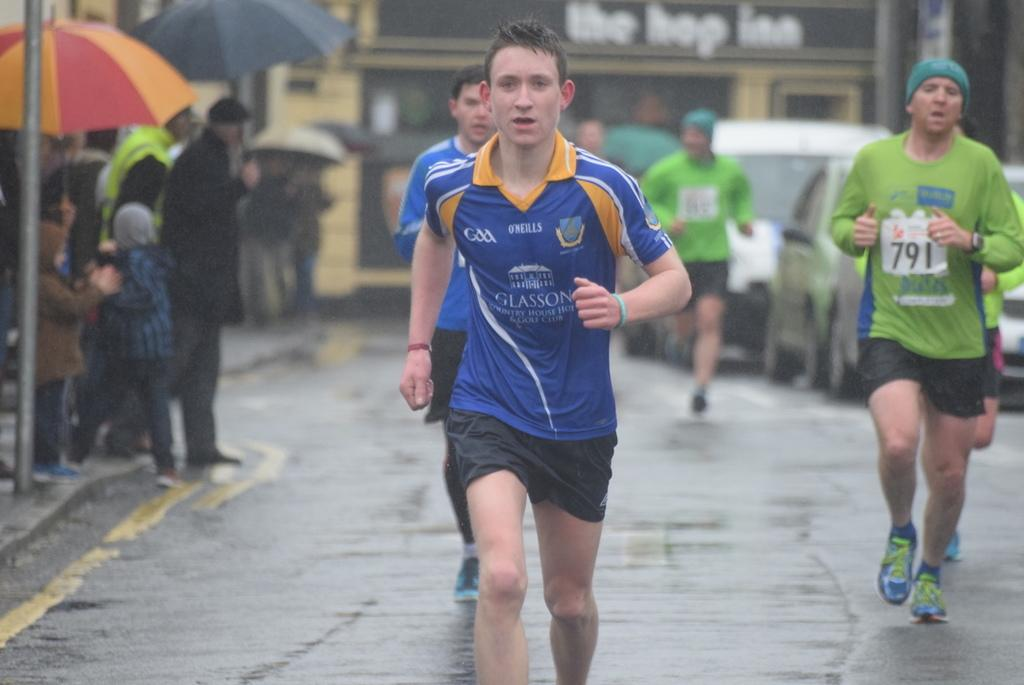Who or what can be seen in the image? There are people in the image. What else is present in the image besides people? There are cars and buildings in the image. Are there any objects in the image that might be used for protection from the elements? Yes, there are umbrellas in the image. What type of plastic is used to make the stick in the image? There is no stick present in the image, so it is not possible to determine what type of plastic might be used. 